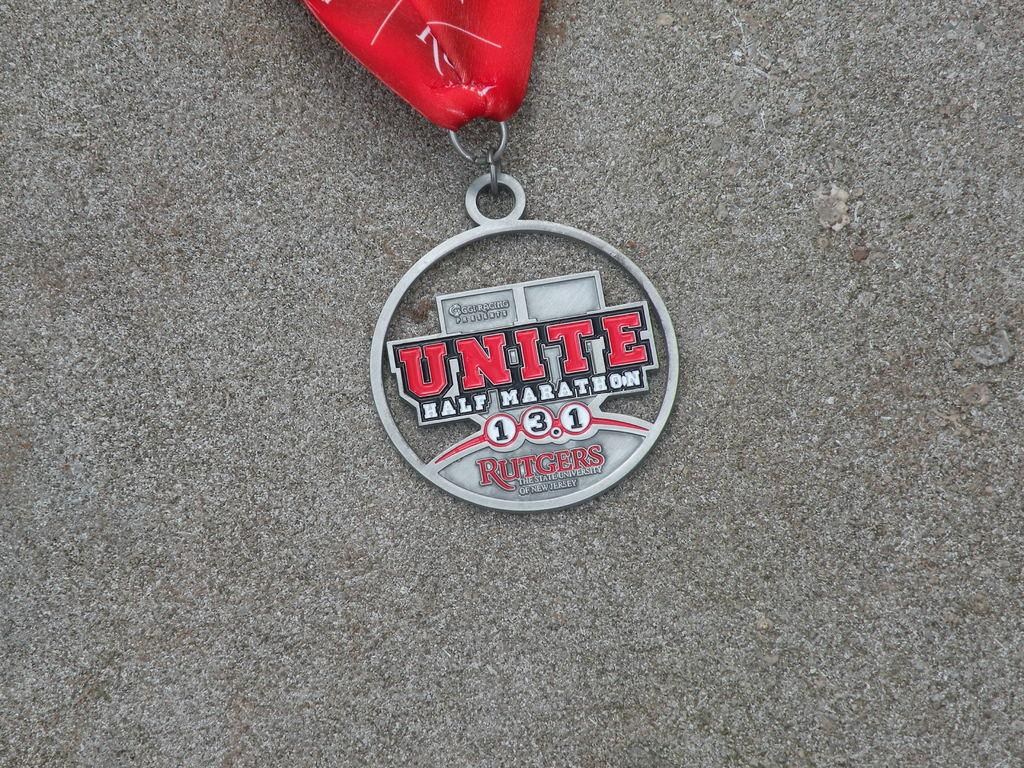What is the main object in the image? There is a keychain in the image. Where is the keychain located? The keychain is on the floor. Can you describe any other objects or colors in the image? There is an object in red color in the background of the image. What type of pest can be seen crawling on the keychain in the image? There is no pest visible on the keychain in the image. Can you describe the scene taking place in the image? The image only shows a keychain on the floor and a red object in the background, so it is not possible to describe a scene taking place. 